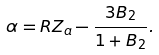<formula> <loc_0><loc_0><loc_500><loc_500>\alpha = R Z _ { a } - \frac { 3 B _ { 2 } } { 1 + B _ { 2 } } .</formula> 